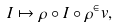<formula> <loc_0><loc_0><loc_500><loc_500>I \mapsto \rho \circ I \circ \rho ^ { \in } v ,</formula> 